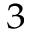<formula> <loc_0><loc_0><loc_500><loc_500>^ { 3 }</formula> 